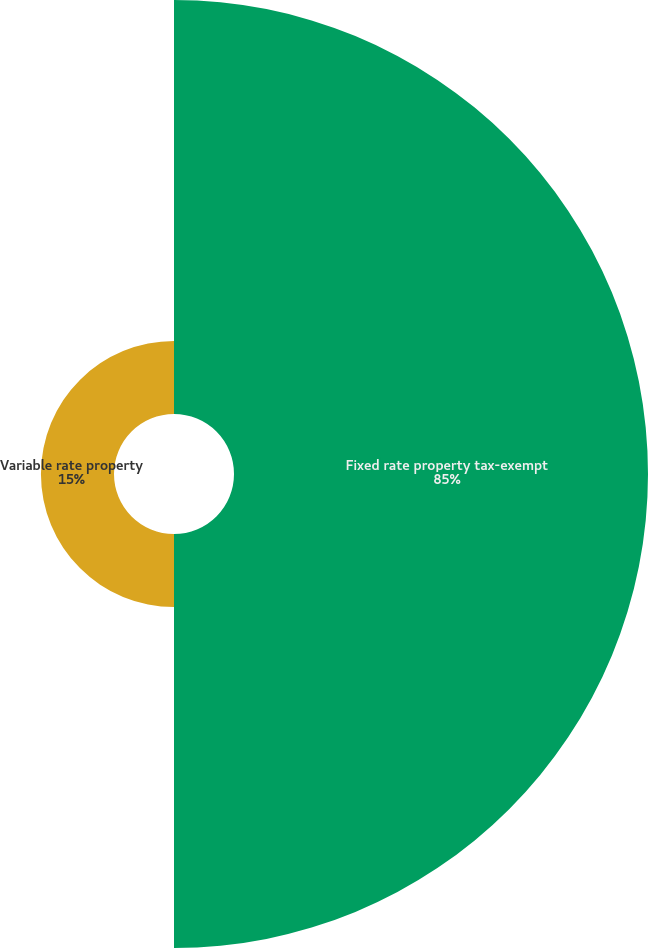Convert chart to OTSL. <chart><loc_0><loc_0><loc_500><loc_500><pie_chart><fcel>Fixed rate property tax-exempt<fcel>Variable rate property<nl><fcel>85.0%<fcel>15.0%<nl></chart> 